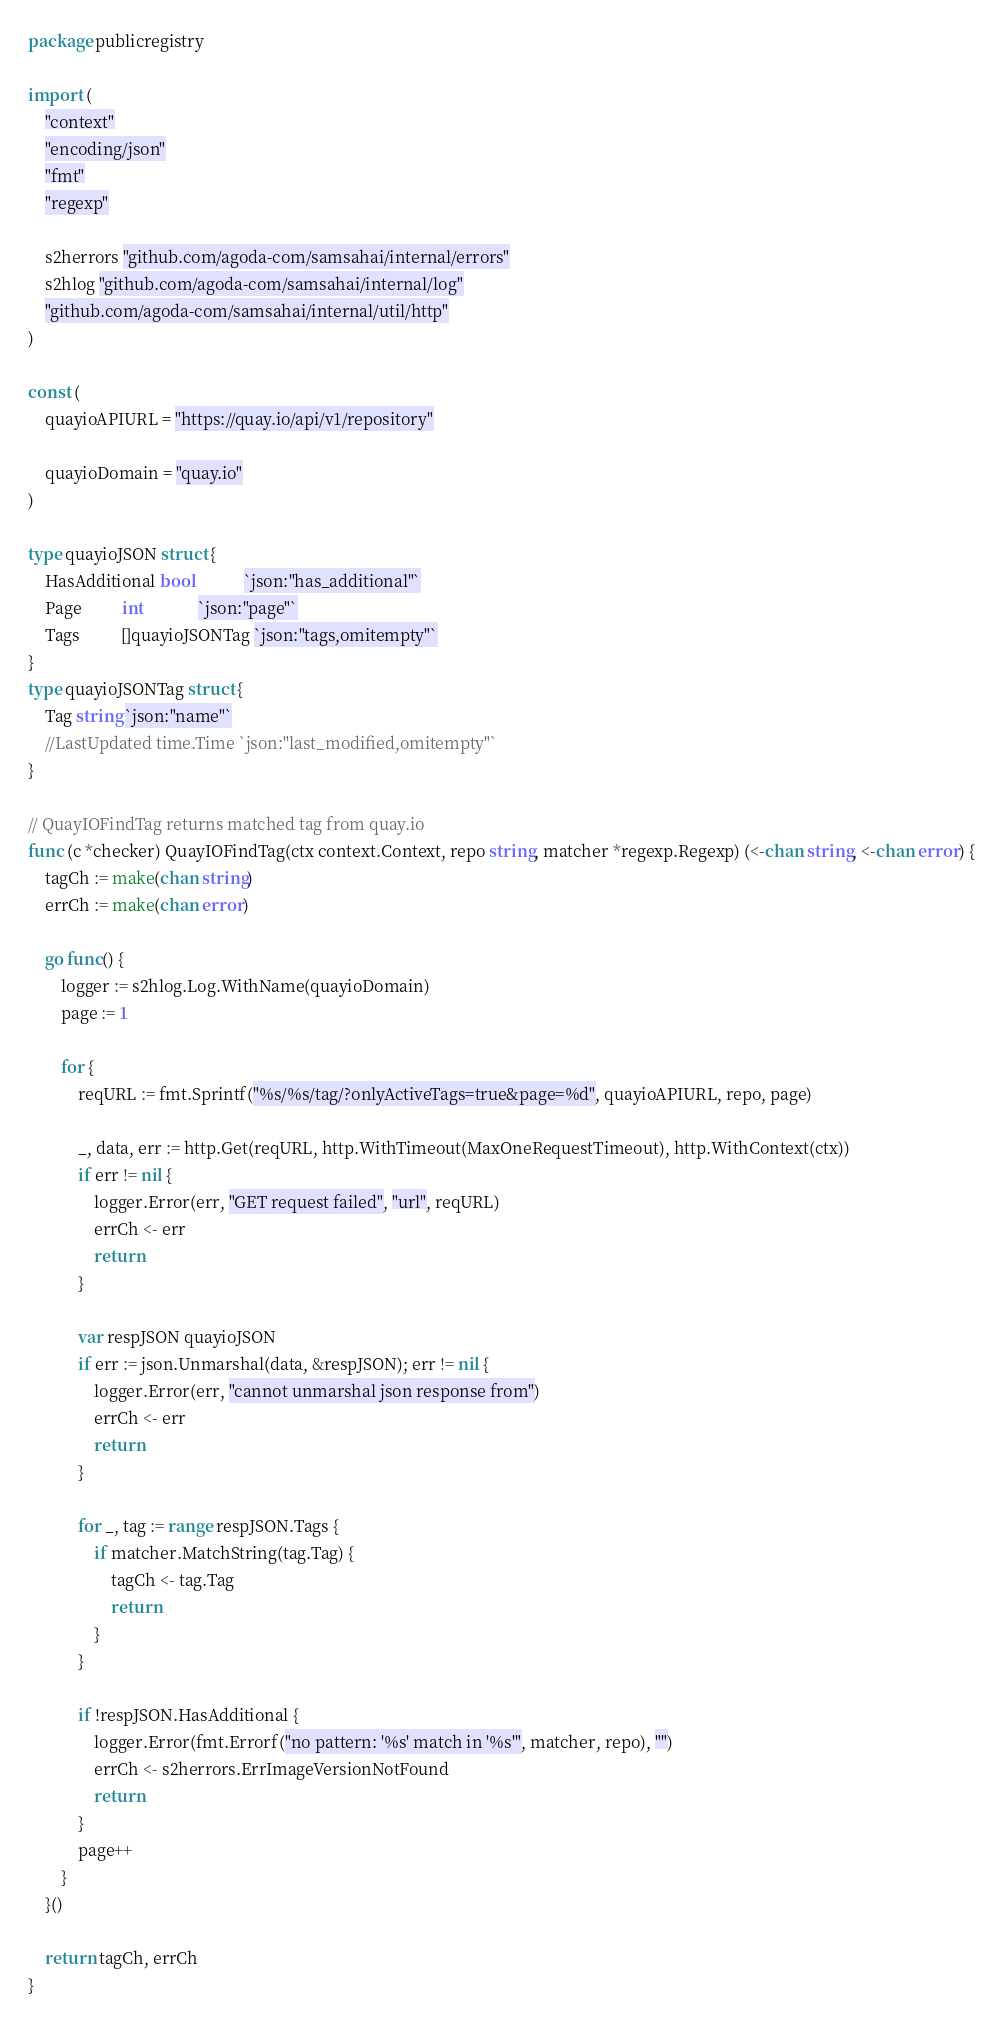<code> <loc_0><loc_0><loc_500><loc_500><_Go_>package publicregistry

import (
	"context"
	"encoding/json"
	"fmt"
	"regexp"

	s2herrors "github.com/agoda-com/samsahai/internal/errors"
	s2hlog "github.com/agoda-com/samsahai/internal/log"
	"github.com/agoda-com/samsahai/internal/util/http"
)

const (
	quayioAPIURL = "https://quay.io/api/v1/repository"

	quayioDomain = "quay.io"
)

type quayioJSON struct {
	HasAdditional bool            `json:"has_additional"`
	Page          int             `json:"page"`
	Tags          []quayioJSONTag `json:"tags,omitempty"`
}
type quayioJSONTag struct {
	Tag string `json:"name"`
	//LastUpdated time.Time `json:"last_modified,omitempty"`
}

// QuayIOFindTag returns matched tag from quay.io
func (c *checker) QuayIOFindTag(ctx context.Context, repo string, matcher *regexp.Regexp) (<-chan string, <-chan error) {
	tagCh := make(chan string)
	errCh := make(chan error)

	go func() {
		logger := s2hlog.Log.WithName(quayioDomain)
		page := 1

		for {
			reqURL := fmt.Sprintf("%s/%s/tag/?onlyActiveTags=true&page=%d", quayioAPIURL, repo, page)

			_, data, err := http.Get(reqURL, http.WithTimeout(MaxOneRequestTimeout), http.WithContext(ctx))
			if err != nil {
				logger.Error(err, "GET request failed", "url", reqURL)
				errCh <- err
				return
			}

			var respJSON quayioJSON
			if err := json.Unmarshal(data, &respJSON); err != nil {
				logger.Error(err, "cannot unmarshal json response from")
				errCh <- err
				return
			}

			for _, tag := range respJSON.Tags {
				if matcher.MatchString(tag.Tag) {
					tagCh <- tag.Tag
					return
				}
			}

			if !respJSON.HasAdditional {
				logger.Error(fmt.Errorf("no pattern: '%s' match in '%s'", matcher, repo), "")
				errCh <- s2herrors.ErrImageVersionNotFound
				return
			}
			page++
		}
	}()

	return tagCh, errCh
}
</code> 